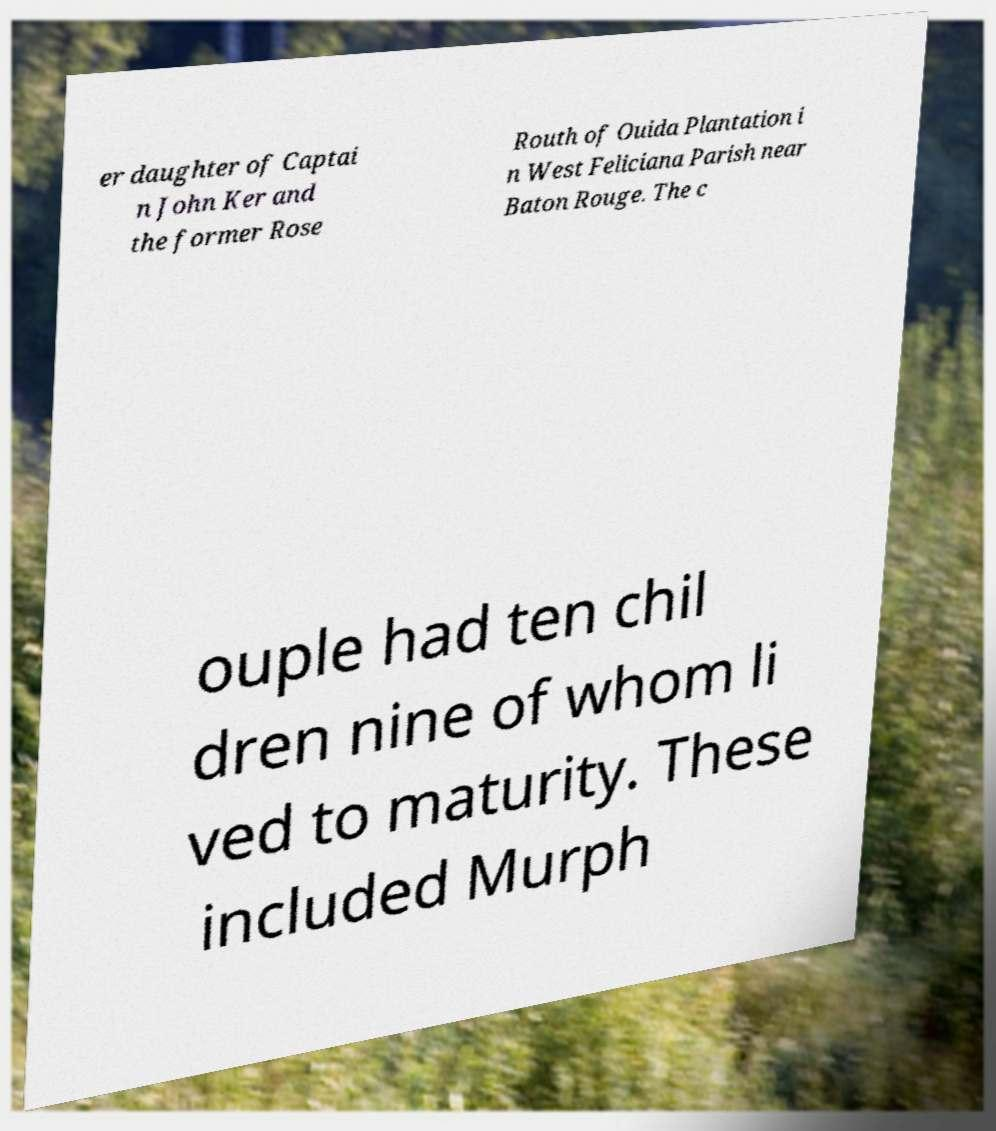What messages or text are displayed in this image? I need them in a readable, typed format. er daughter of Captai n John Ker and the former Rose Routh of Ouida Plantation i n West Feliciana Parish near Baton Rouge. The c ouple had ten chil dren nine of whom li ved to maturity. These included Murph 